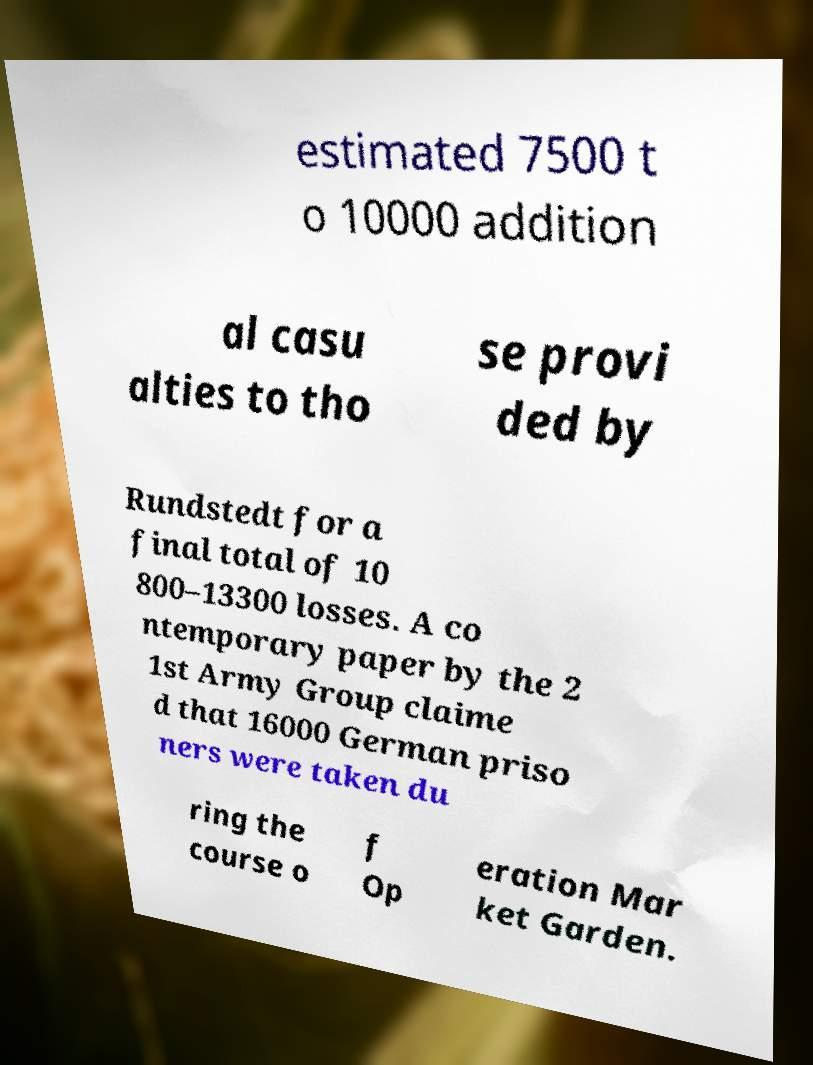Could you assist in decoding the text presented in this image and type it out clearly? estimated 7500 t o 10000 addition al casu alties to tho se provi ded by Rundstedt for a final total of 10 800–13300 losses. A co ntemporary paper by the 2 1st Army Group claime d that 16000 German priso ners were taken du ring the course o f Op eration Mar ket Garden. 